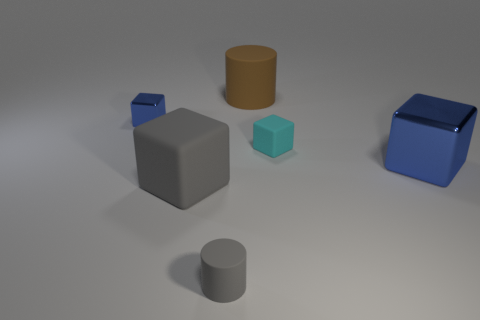What is the tiny object that is behind the large blue shiny thing and to the left of the small rubber cube made of?
Ensure brevity in your answer.  Metal. What number of small objects are gray rubber objects or blue objects?
Keep it short and to the point. 2. What size is the gray matte cube?
Make the answer very short. Large. What is the shape of the large blue shiny thing?
Ensure brevity in your answer.  Cube. Are there any other things that are the same shape as the big brown thing?
Offer a very short reply. Yes. Is the number of brown rubber cylinders that are on the left side of the small rubber cylinder less than the number of rubber objects?
Provide a succinct answer. Yes. There is a tiny block that is on the left side of the large gray block; does it have the same color as the tiny matte cube?
Make the answer very short. No. What number of matte objects are either cubes or cyan blocks?
Offer a very short reply. 2. Are there any other things that are the same size as the brown cylinder?
Offer a very short reply. Yes. There is another cylinder that is made of the same material as the big brown cylinder; what is its color?
Keep it short and to the point. Gray. 